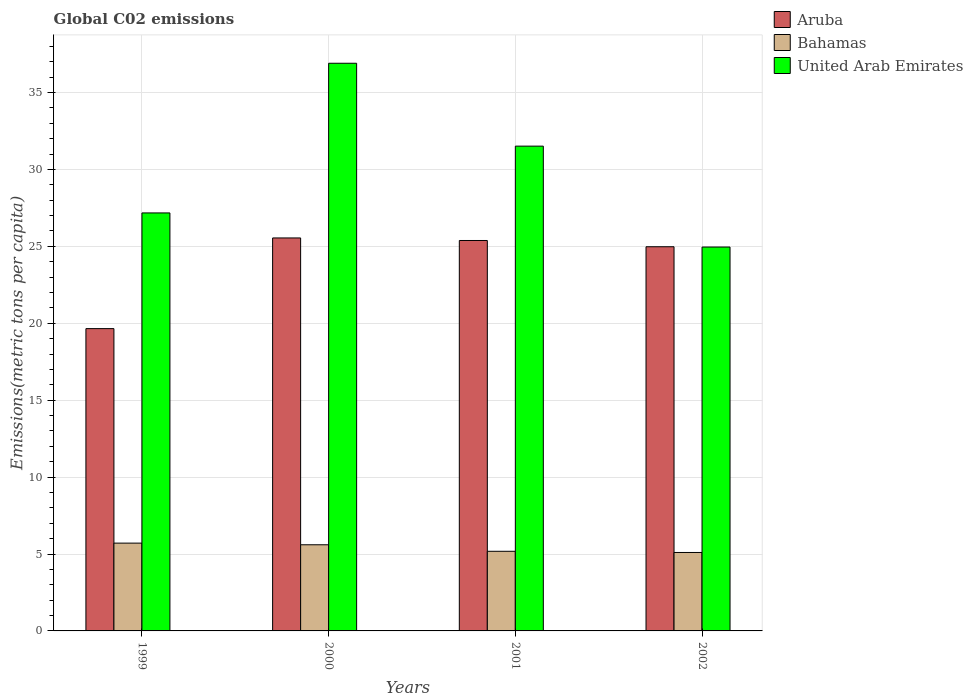How many different coloured bars are there?
Ensure brevity in your answer.  3. How many groups of bars are there?
Your answer should be very brief. 4. Are the number of bars per tick equal to the number of legend labels?
Your answer should be very brief. Yes. Are the number of bars on each tick of the X-axis equal?
Keep it short and to the point. Yes. How many bars are there on the 2nd tick from the left?
Provide a succinct answer. 3. How many bars are there on the 4th tick from the right?
Your answer should be compact. 3. What is the label of the 4th group of bars from the left?
Offer a terse response. 2002. What is the amount of CO2 emitted in in Aruba in 2002?
Your answer should be very brief. 24.98. Across all years, what is the maximum amount of CO2 emitted in in United Arab Emirates?
Make the answer very short. 36.9. Across all years, what is the minimum amount of CO2 emitted in in Aruba?
Make the answer very short. 19.65. In which year was the amount of CO2 emitted in in Aruba minimum?
Keep it short and to the point. 1999. What is the total amount of CO2 emitted in in Bahamas in the graph?
Keep it short and to the point. 21.59. What is the difference between the amount of CO2 emitted in in United Arab Emirates in 2000 and that in 2002?
Provide a succinct answer. 11.95. What is the difference between the amount of CO2 emitted in in Bahamas in 2000 and the amount of CO2 emitted in in United Arab Emirates in 2001?
Your response must be concise. -25.92. What is the average amount of CO2 emitted in in Aruba per year?
Offer a terse response. 23.89. In the year 2002, what is the difference between the amount of CO2 emitted in in United Arab Emirates and amount of CO2 emitted in in Aruba?
Give a very brief answer. -0.02. What is the ratio of the amount of CO2 emitted in in Aruba in 2000 to that in 2001?
Ensure brevity in your answer.  1.01. Is the amount of CO2 emitted in in United Arab Emirates in 1999 less than that in 2001?
Offer a terse response. Yes. Is the difference between the amount of CO2 emitted in in United Arab Emirates in 1999 and 2000 greater than the difference between the amount of CO2 emitted in in Aruba in 1999 and 2000?
Provide a succinct answer. No. What is the difference between the highest and the second highest amount of CO2 emitted in in United Arab Emirates?
Offer a very short reply. 5.39. What is the difference between the highest and the lowest amount of CO2 emitted in in Aruba?
Keep it short and to the point. 5.9. In how many years, is the amount of CO2 emitted in in Aruba greater than the average amount of CO2 emitted in in Aruba taken over all years?
Offer a very short reply. 3. Is the sum of the amount of CO2 emitted in in Bahamas in 1999 and 2002 greater than the maximum amount of CO2 emitted in in Aruba across all years?
Make the answer very short. No. What does the 3rd bar from the left in 2001 represents?
Ensure brevity in your answer.  United Arab Emirates. What does the 3rd bar from the right in 2001 represents?
Ensure brevity in your answer.  Aruba. Are all the bars in the graph horizontal?
Ensure brevity in your answer.  No. What is the difference between two consecutive major ticks on the Y-axis?
Offer a very short reply. 5. Does the graph contain grids?
Your response must be concise. Yes. How many legend labels are there?
Your response must be concise. 3. How are the legend labels stacked?
Make the answer very short. Vertical. What is the title of the graph?
Provide a short and direct response. Global C02 emissions. Does "South Asia" appear as one of the legend labels in the graph?
Make the answer very short. No. What is the label or title of the X-axis?
Offer a terse response. Years. What is the label or title of the Y-axis?
Keep it short and to the point. Emissions(metric tons per capita). What is the Emissions(metric tons per capita) in Aruba in 1999?
Offer a very short reply. 19.65. What is the Emissions(metric tons per capita) in Bahamas in 1999?
Provide a short and direct response. 5.71. What is the Emissions(metric tons per capita) of United Arab Emirates in 1999?
Your answer should be very brief. 27.17. What is the Emissions(metric tons per capita) in Aruba in 2000?
Your response must be concise. 25.55. What is the Emissions(metric tons per capita) in Bahamas in 2000?
Your answer should be very brief. 5.6. What is the Emissions(metric tons per capita) of United Arab Emirates in 2000?
Your response must be concise. 36.9. What is the Emissions(metric tons per capita) of Aruba in 2001?
Provide a short and direct response. 25.38. What is the Emissions(metric tons per capita) of Bahamas in 2001?
Your response must be concise. 5.18. What is the Emissions(metric tons per capita) in United Arab Emirates in 2001?
Provide a short and direct response. 31.52. What is the Emissions(metric tons per capita) of Aruba in 2002?
Offer a very short reply. 24.98. What is the Emissions(metric tons per capita) in Bahamas in 2002?
Keep it short and to the point. 5.1. What is the Emissions(metric tons per capita) in United Arab Emirates in 2002?
Provide a succinct answer. 24.96. Across all years, what is the maximum Emissions(metric tons per capita) of Aruba?
Provide a succinct answer. 25.55. Across all years, what is the maximum Emissions(metric tons per capita) of Bahamas?
Give a very brief answer. 5.71. Across all years, what is the maximum Emissions(metric tons per capita) of United Arab Emirates?
Provide a succinct answer. 36.9. Across all years, what is the minimum Emissions(metric tons per capita) of Aruba?
Keep it short and to the point. 19.65. Across all years, what is the minimum Emissions(metric tons per capita) in Bahamas?
Ensure brevity in your answer.  5.1. Across all years, what is the minimum Emissions(metric tons per capita) in United Arab Emirates?
Make the answer very short. 24.96. What is the total Emissions(metric tons per capita) of Aruba in the graph?
Your answer should be very brief. 95.56. What is the total Emissions(metric tons per capita) of Bahamas in the graph?
Your answer should be compact. 21.59. What is the total Emissions(metric tons per capita) of United Arab Emirates in the graph?
Provide a short and direct response. 120.55. What is the difference between the Emissions(metric tons per capita) of Aruba in 1999 and that in 2000?
Your answer should be compact. -5.9. What is the difference between the Emissions(metric tons per capita) in Bahamas in 1999 and that in 2000?
Your answer should be compact. 0.11. What is the difference between the Emissions(metric tons per capita) of United Arab Emirates in 1999 and that in 2000?
Keep it short and to the point. -9.73. What is the difference between the Emissions(metric tons per capita) in Aruba in 1999 and that in 2001?
Your answer should be very brief. -5.73. What is the difference between the Emissions(metric tons per capita) of Bahamas in 1999 and that in 2001?
Your response must be concise. 0.53. What is the difference between the Emissions(metric tons per capita) in United Arab Emirates in 1999 and that in 2001?
Your answer should be compact. -4.34. What is the difference between the Emissions(metric tons per capita) of Aruba in 1999 and that in 2002?
Give a very brief answer. -5.32. What is the difference between the Emissions(metric tons per capita) in Bahamas in 1999 and that in 2002?
Offer a terse response. 0.61. What is the difference between the Emissions(metric tons per capita) in United Arab Emirates in 1999 and that in 2002?
Offer a terse response. 2.22. What is the difference between the Emissions(metric tons per capita) of Aruba in 2000 and that in 2001?
Provide a succinct answer. 0.17. What is the difference between the Emissions(metric tons per capita) of Bahamas in 2000 and that in 2001?
Your answer should be very brief. 0.42. What is the difference between the Emissions(metric tons per capita) of United Arab Emirates in 2000 and that in 2001?
Provide a succinct answer. 5.39. What is the difference between the Emissions(metric tons per capita) in Aruba in 2000 and that in 2002?
Provide a succinct answer. 0.57. What is the difference between the Emissions(metric tons per capita) of Bahamas in 2000 and that in 2002?
Your response must be concise. 0.5. What is the difference between the Emissions(metric tons per capita) of United Arab Emirates in 2000 and that in 2002?
Provide a succinct answer. 11.95. What is the difference between the Emissions(metric tons per capita) of Aruba in 2001 and that in 2002?
Provide a succinct answer. 0.41. What is the difference between the Emissions(metric tons per capita) in Bahamas in 2001 and that in 2002?
Offer a very short reply. 0.08. What is the difference between the Emissions(metric tons per capita) in United Arab Emirates in 2001 and that in 2002?
Your answer should be very brief. 6.56. What is the difference between the Emissions(metric tons per capita) in Aruba in 1999 and the Emissions(metric tons per capita) in Bahamas in 2000?
Offer a terse response. 14.05. What is the difference between the Emissions(metric tons per capita) of Aruba in 1999 and the Emissions(metric tons per capita) of United Arab Emirates in 2000?
Offer a terse response. -17.25. What is the difference between the Emissions(metric tons per capita) of Bahamas in 1999 and the Emissions(metric tons per capita) of United Arab Emirates in 2000?
Provide a short and direct response. -31.2. What is the difference between the Emissions(metric tons per capita) of Aruba in 1999 and the Emissions(metric tons per capita) of Bahamas in 2001?
Keep it short and to the point. 14.48. What is the difference between the Emissions(metric tons per capita) of Aruba in 1999 and the Emissions(metric tons per capita) of United Arab Emirates in 2001?
Your response must be concise. -11.86. What is the difference between the Emissions(metric tons per capita) in Bahamas in 1999 and the Emissions(metric tons per capita) in United Arab Emirates in 2001?
Make the answer very short. -25.81. What is the difference between the Emissions(metric tons per capita) of Aruba in 1999 and the Emissions(metric tons per capita) of Bahamas in 2002?
Offer a terse response. 14.55. What is the difference between the Emissions(metric tons per capita) in Aruba in 1999 and the Emissions(metric tons per capita) in United Arab Emirates in 2002?
Provide a succinct answer. -5.3. What is the difference between the Emissions(metric tons per capita) of Bahamas in 1999 and the Emissions(metric tons per capita) of United Arab Emirates in 2002?
Your answer should be very brief. -19.25. What is the difference between the Emissions(metric tons per capita) of Aruba in 2000 and the Emissions(metric tons per capita) of Bahamas in 2001?
Ensure brevity in your answer.  20.37. What is the difference between the Emissions(metric tons per capita) in Aruba in 2000 and the Emissions(metric tons per capita) in United Arab Emirates in 2001?
Provide a succinct answer. -5.97. What is the difference between the Emissions(metric tons per capita) of Bahamas in 2000 and the Emissions(metric tons per capita) of United Arab Emirates in 2001?
Provide a short and direct response. -25.92. What is the difference between the Emissions(metric tons per capita) in Aruba in 2000 and the Emissions(metric tons per capita) in Bahamas in 2002?
Offer a terse response. 20.45. What is the difference between the Emissions(metric tons per capita) of Aruba in 2000 and the Emissions(metric tons per capita) of United Arab Emirates in 2002?
Your answer should be compact. 0.59. What is the difference between the Emissions(metric tons per capita) in Bahamas in 2000 and the Emissions(metric tons per capita) in United Arab Emirates in 2002?
Provide a short and direct response. -19.36. What is the difference between the Emissions(metric tons per capita) of Aruba in 2001 and the Emissions(metric tons per capita) of Bahamas in 2002?
Make the answer very short. 20.28. What is the difference between the Emissions(metric tons per capita) of Aruba in 2001 and the Emissions(metric tons per capita) of United Arab Emirates in 2002?
Offer a very short reply. 0.43. What is the difference between the Emissions(metric tons per capita) in Bahamas in 2001 and the Emissions(metric tons per capita) in United Arab Emirates in 2002?
Your answer should be compact. -19.78. What is the average Emissions(metric tons per capita) in Aruba per year?
Your answer should be very brief. 23.89. What is the average Emissions(metric tons per capita) of Bahamas per year?
Your response must be concise. 5.4. What is the average Emissions(metric tons per capita) of United Arab Emirates per year?
Keep it short and to the point. 30.14. In the year 1999, what is the difference between the Emissions(metric tons per capita) in Aruba and Emissions(metric tons per capita) in Bahamas?
Give a very brief answer. 13.94. In the year 1999, what is the difference between the Emissions(metric tons per capita) of Aruba and Emissions(metric tons per capita) of United Arab Emirates?
Your response must be concise. -7.52. In the year 1999, what is the difference between the Emissions(metric tons per capita) in Bahamas and Emissions(metric tons per capita) in United Arab Emirates?
Your response must be concise. -21.47. In the year 2000, what is the difference between the Emissions(metric tons per capita) of Aruba and Emissions(metric tons per capita) of Bahamas?
Your answer should be very brief. 19.95. In the year 2000, what is the difference between the Emissions(metric tons per capita) in Aruba and Emissions(metric tons per capita) in United Arab Emirates?
Keep it short and to the point. -11.36. In the year 2000, what is the difference between the Emissions(metric tons per capita) of Bahamas and Emissions(metric tons per capita) of United Arab Emirates?
Give a very brief answer. -31.3. In the year 2001, what is the difference between the Emissions(metric tons per capita) of Aruba and Emissions(metric tons per capita) of Bahamas?
Offer a terse response. 20.21. In the year 2001, what is the difference between the Emissions(metric tons per capita) in Aruba and Emissions(metric tons per capita) in United Arab Emirates?
Provide a succinct answer. -6.13. In the year 2001, what is the difference between the Emissions(metric tons per capita) of Bahamas and Emissions(metric tons per capita) of United Arab Emirates?
Offer a terse response. -26.34. In the year 2002, what is the difference between the Emissions(metric tons per capita) in Aruba and Emissions(metric tons per capita) in Bahamas?
Provide a succinct answer. 19.88. In the year 2002, what is the difference between the Emissions(metric tons per capita) in Aruba and Emissions(metric tons per capita) in United Arab Emirates?
Offer a very short reply. 0.02. In the year 2002, what is the difference between the Emissions(metric tons per capita) in Bahamas and Emissions(metric tons per capita) in United Arab Emirates?
Offer a very short reply. -19.86. What is the ratio of the Emissions(metric tons per capita) in Aruba in 1999 to that in 2000?
Offer a very short reply. 0.77. What is the ratio of the Emissions(metric tons per capita) of Bahamas in 1999 to that in 2000?
Offer a terse response. 1.02. What is the ratio of the Emissions(metric tons per capita) of United Arab Emirates in 1999 to that in 2000?
Provide a short and direct response. 0.74. What is the ratio of the Emissions(metric tons per capita) in Aruba in 1999 to that in 2001?
Offer a terse response. 0.77. What is the ratio of the Emissions(metric tons per capita) in Bahamas in 1999 to that in 2001?
Give a very brief answer. 1.1. What is the ratio of the Emissions(metric tons per capita) of United Arab Emirates in 1999 to that in 2001?
Provide a short and direct response. 0.86. What is the ratio of the Emissions(metric tons per capita) in Aruba in 1999 to that in 2002?
Your response must be concise. 0.79. What is the ratio of the Emissions(metric tons per capita) of Bahamas in 1999 to that in 2002?
Your answer should be very brief. 1.12. What is the ratio of the Emissions(metric tons per capita) of United Arab Emirates in 1999 to that in 2002?
Make the answer very short. 1.09. What is the ratio of the Emissions(metric tons per capita) of Aruba in 2000 to that in 2001?
Ensure brevity in your answer.  1.01. What is the ratio of the Emissions(metric tons per capita) of Bahamas in 2000 to that in 2001?
Your answer should be compact. 1.08. What is the ratio of the Emissions(metric tons per capita) of United Arab Emirates in 2000 to that in 2001?
Your answer should be very brief. 1.17. What is the ratio of the Emissions(metric tons per capita) in Aruba in 2000 to that in 2002?
Provide a short and direct response. 1.02. What is the ratio of the Emissions(metric tons per capita) in Bahamas in 2000 to that in 2002?
Your response must be concise. 1.1. What is the ratio of the Emissions(metric tons per capita) in United Arab Emirates in 2000 to that in 2002?
Your response must be concise. 1.48. What is the ratio of the Emissions(metric tons per capita) of Aruba in 2001 to that in 2002?
Give a very brief answer. 1.02. What is the ratio of the Emissions(metric tons per capita) of Bahamas in 2001 to that in 2002?
Offer a very short reply. 1.02. What is the ratio of the Emissions(metric tons per capita) of United Arab Emirates in 2001 to that in 2002?
Offer a very short reply. 1.26. What is the difference between the highest and the second highest Emissions(metric tons per capita) in Aruba?
Give a very brief answer. 0.17. What is the difference between the highest and the second highest Emissions(metric tons per capita) in Bahamas?
Your answer should be very brief. 0.11. What is the difference between the highest and the second highest Emissions(metric tons per capita) of United Arab Emirates?
Keep it short and to the point. 5.39. What is the difference between the highest and the lowest Emissions(metric tons per capita) of Aruba?
Provide a succinct answer. 5.9. What is the difference between the highest and the lowest Emissions(metric tons per capita) in Bahamas?
Make the answer very short. 0.61. What is the difference between the highest and the lowest Emissions(metric tons per capita) in United Arab Emirates?
Your response must be concise. 11.95. 